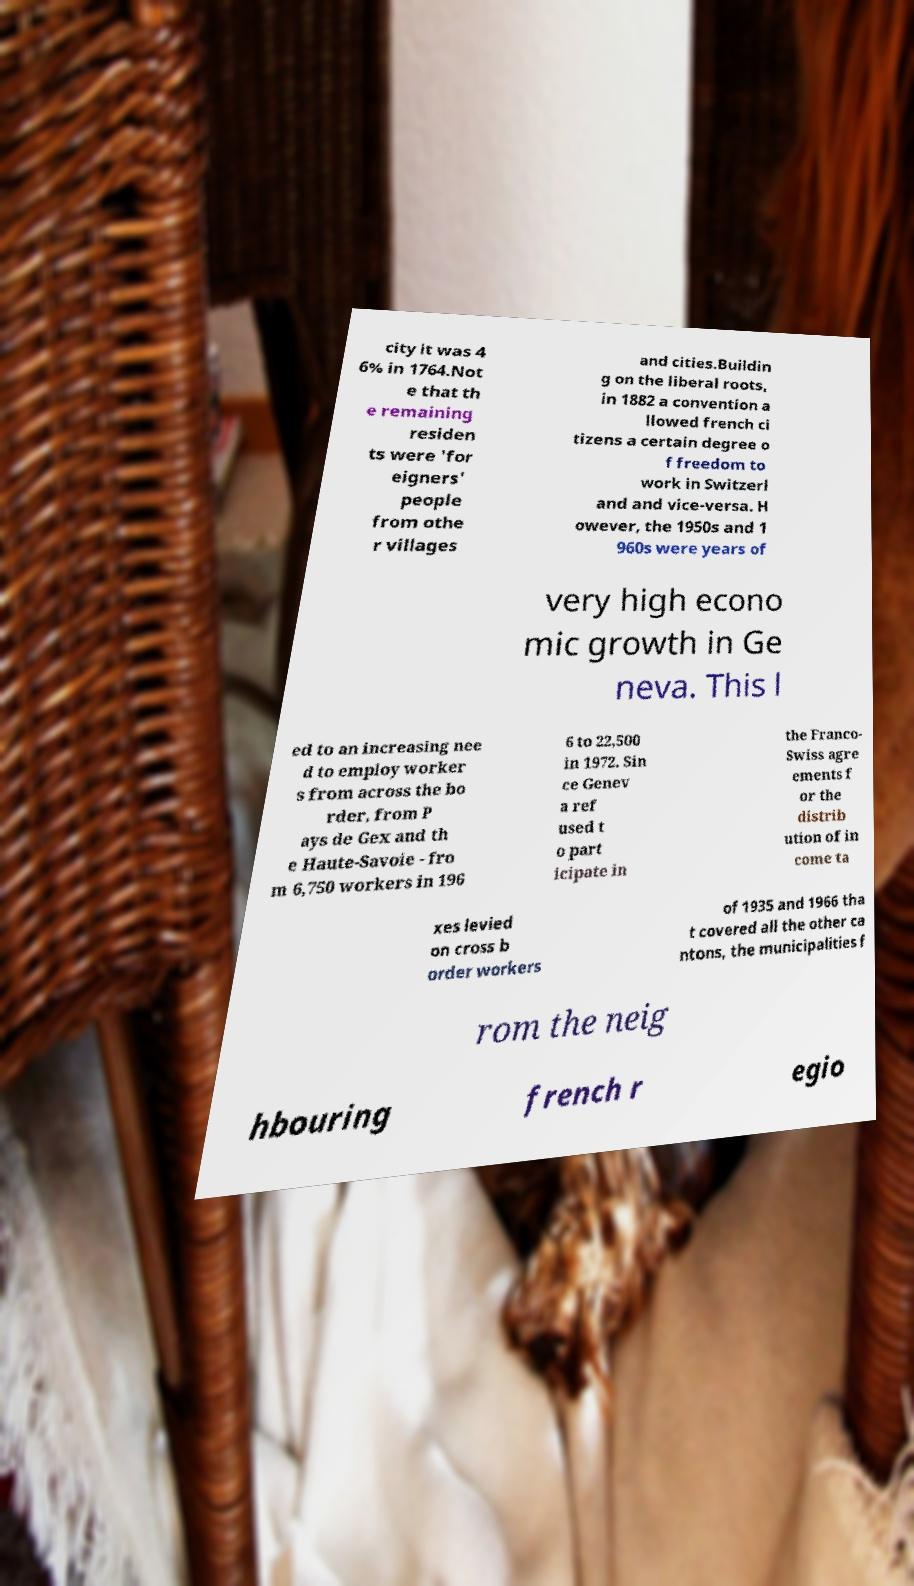There's text embedded in this image that I need extracted. Can you transcribe it verbatim? city it was 4 6% in 1764.Not e that th e remaining residen ts were 'for eigners' people from othe r villages and cities.Buildin g on the liberal roots, in 1882 a convention a llowed french ci tizens a certain degree o f freedom to work in Switzerl and and vice-versa. H owever, the 1950s and 1 960s were years of very high econo mic growth in Ge neva. This l ed to an increasing nee d to employ worker s from across the bo rder, from P ays de Gex and th e Haute-Savoie - fro m 6,750 workers in 196 6 to 22,500 in 1972. Sin ce Genev a ref used t o part icipate in the Franco- Swiss agre ements f or the distrib ution of in come ta xes levied on cross b order workers of 1935 and 1966 tha t covered all the other ca ntons, the municipalities f rom the neig hbouring french r egio 